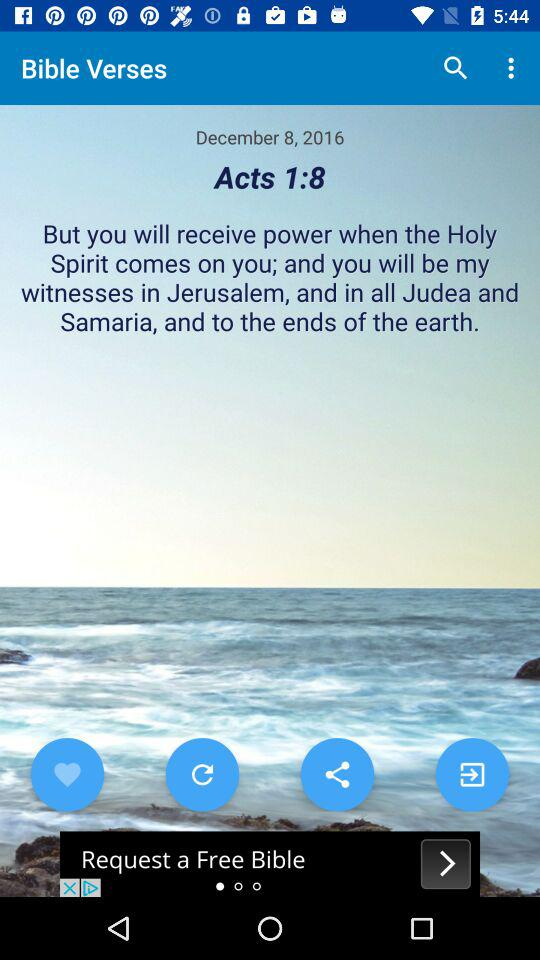Which "Bible" verse is currently shown? The "Bible" verse that is currently shown is "Acts 1:8". 